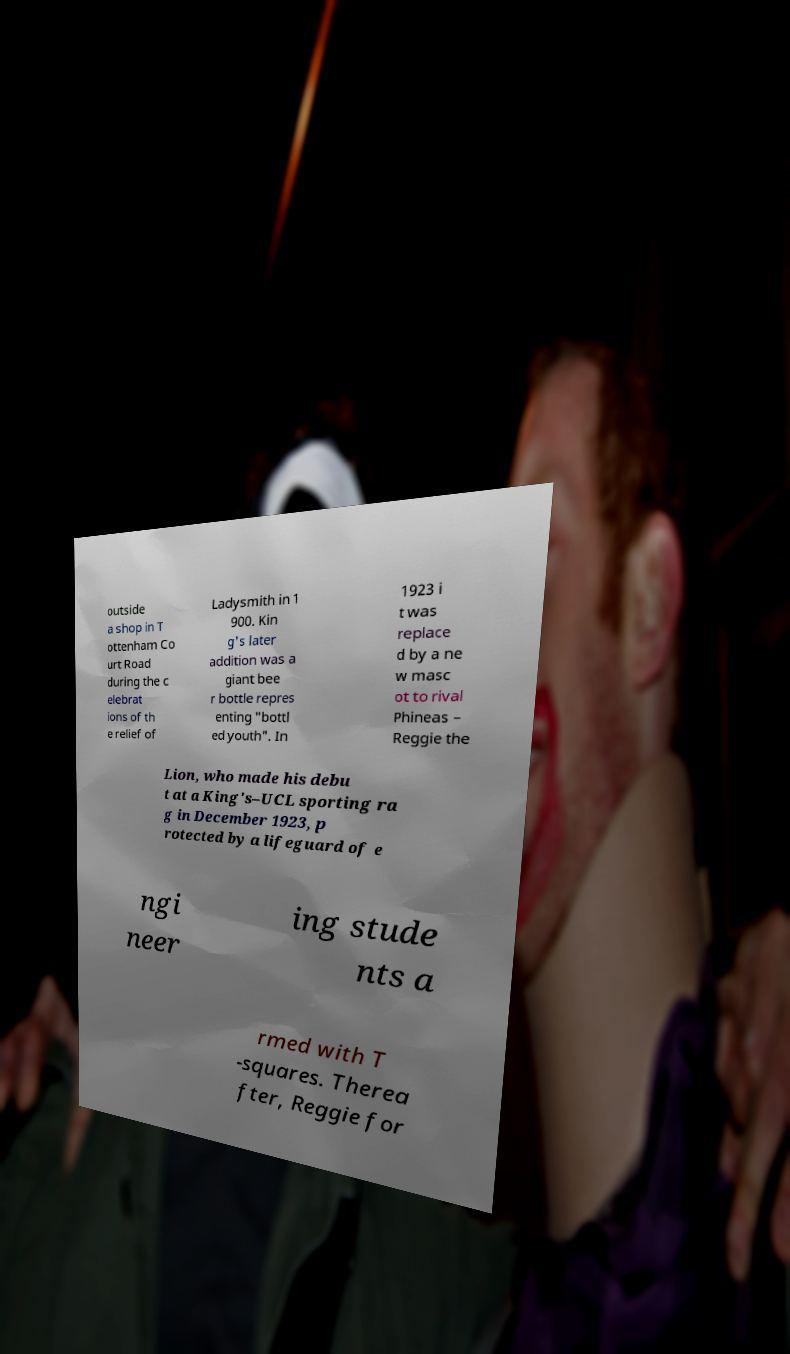What messages or text are displayed in this image? I need them in a readable, typed format. outside a shop in T ottenham Co urt Road during the c elebrat ions of th e relief of Ladysmith in 1 900. Kin g's later addition was a giant bee r bottle repres enting "bottl ed youth". In 1923 i t was replace d by a ne w masc ot to rival Phineas – Reggie the Lion, who made his debu t at a King's–UCL sporting ra g in December 1923, p rotected by a lifeguard of e ngi neer ing stude nts a rmed with T -squares. Therea fter, Reggie for 